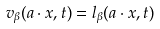Convert formula to latex. <formula><loc_0><loc_0><loc_500><loc_500>v _ { \beta } ( a \cdot x , t ) = l _ { \beta } ( a \cdot x , t )</formula> 